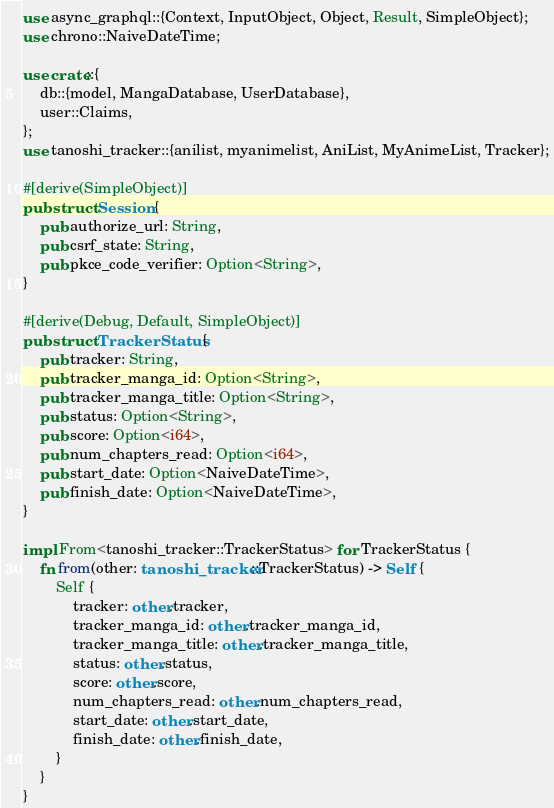Convert code to text. <code><loc_0><loc_0><loc_500><loc_500><_Rust_>use async_graphql::{Context, InputObject, Object, Result, SimpleObject};
use chrono::NaiveDateTime;

use crate::{
    db::{model, MangaDatabase, UserDatabase},
    user::Claims,
};
use tanoshi_tracker::{anilist, myanimelist, AniList, MyAnimeList, Tracker};

#[derive(SimpleObject)]
pub struct Session {
    pub authorize_url: String,
    pub csrf_state: String,
    pub pkce_code_verifier: Option<String>,
}

#[derive(Debug, Default, SimpleObject)]
pub struct TrackerStatus {
    pub tracker: String,
    pub tracker_manga_id: Option<String>,
    pub tracker_manga_title: Option<String>,
    pub status: Option<String>,
    pub score: Option<i64>,
    pub num_chapters_read: Option<i64>,
    pub start_date: Option<NaiveDateTime>,
    pub finish_date: Option<NaiveDateTime>,
}

impl From<tanoshi_tracker::TrackerStatus> for TrackerStatus {
    fn from(other: tanoshi_tracker::TrackerStatus) -> Self {
        Self {
            tracker: other.tracker,
            tracker_manga_id: other.tracker_manga_id,
            tracker_manga_title: other.tracker_manga_title,
            status: other.status,
            score: other.score,
            num_chapters_read: other.num_chapters_read,
            start_date: other.start_date,
            finish_date: other.finish_date,
        }
    }
}
</code> 